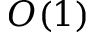<formula> <loc_0><loc_0><loc_500><loc_500>O ( 1 )</formula> 